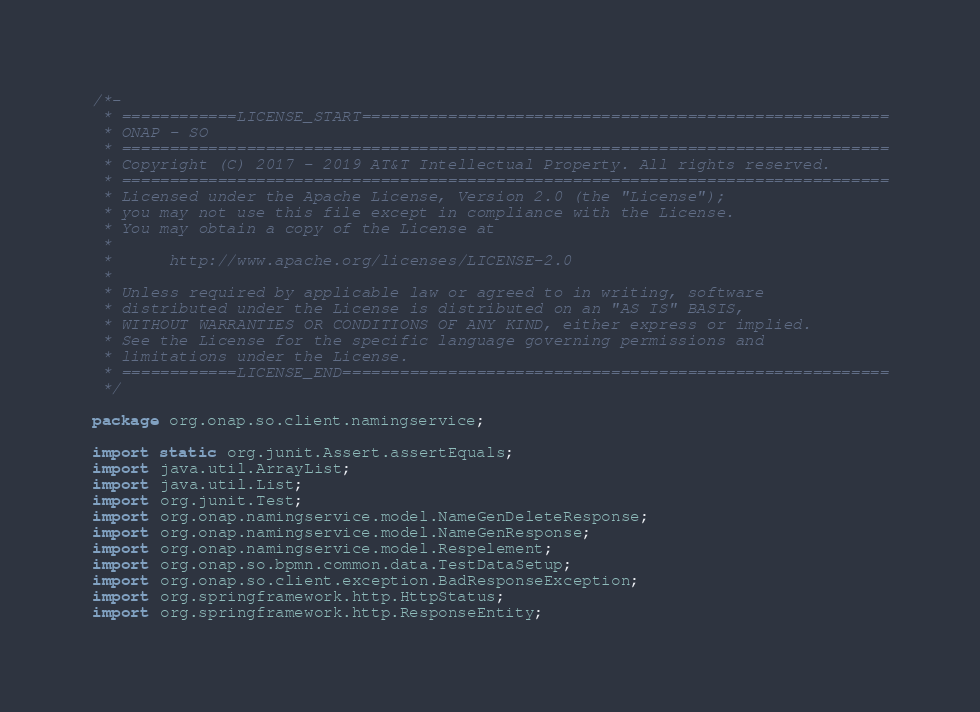<code> <loc_0><loc_0><loc_500><loc_500><_Java_>/*-
 * ============LICENSE_START=======================================================
 * ONAP - SO
 * ================================================================================
 * Copyright (C) 2017 - 2019 AT&T Intellectual Property. All rights reserved.
 * ================================================================================
 * Licensed under the Apache License, Version 2.0 (the "License");
 * you may not use this file except in compliance with the License.
 * You may obtain a copy of the License at
 * 
 *      http://www.apache.org/licenses/LICENSE-2.0
 * 
 * Unless required by applicable law or agreed to in writing, software
 * distributed under the License is distributed on an "AS IS" BASIS,
 * WITHOUT WARRANTIES OR CONDITIONS OF ANY KIND, either express or implied.
 * See the License for the specific language governing permissions and
 * limitations under the License.
 * ============LICENSE_END=========================================================
 */

package org.onap.so.client.namingservice;

import static org.junit.Assert.assertEquals;
import java.util.ArrayList;
import java.util.List;
import org.junit.Test;
import org.onap.namingservice.model.NameGenDeleteResponse;
import org.onap.namingservice.model.NameGenResponse;
import org.onap.namingservice.model.Respelement;
import org.onap.so.bpmn.common.data.TestDataSetup;
import org.onap.so.client.exception.BadResponseException;
import org.springframework.http.HttpStatus;
import org.springframework.http.ResponseEntity;
</code> 